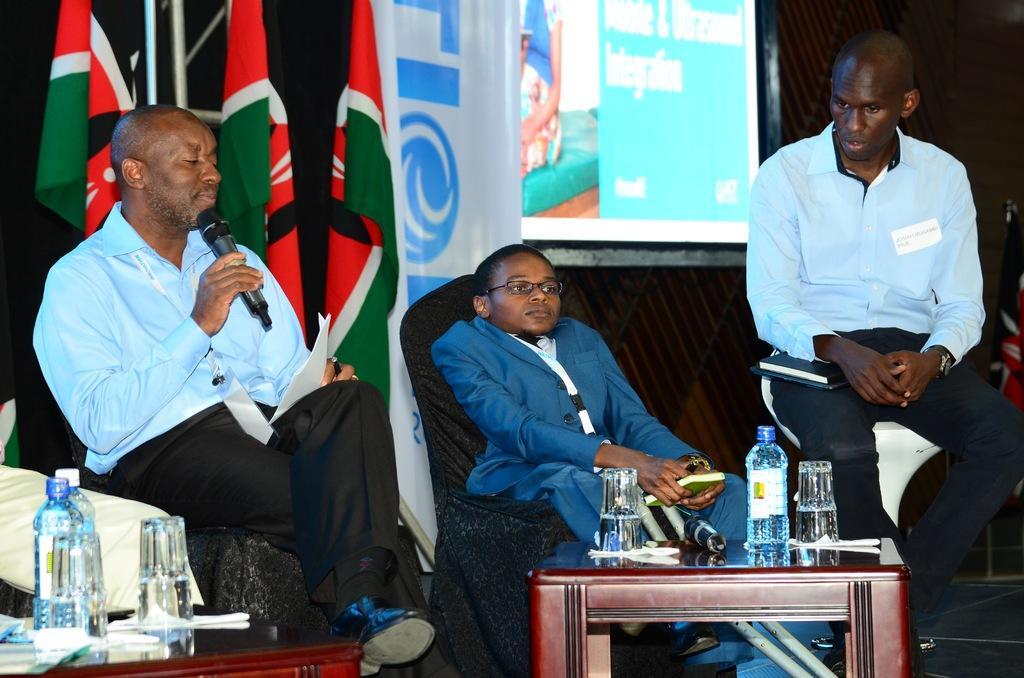How would you summarize this image in a sentence or two? Here the two people are sitting on the sofa and a person is sitting on the stool. There is a water bottle at here. 